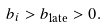Convert formula to latex. <formula><loc_0><loc_0><loc_500><loc_500>b _ { i } > b _ { \text {late} } > 0 .</formula> 